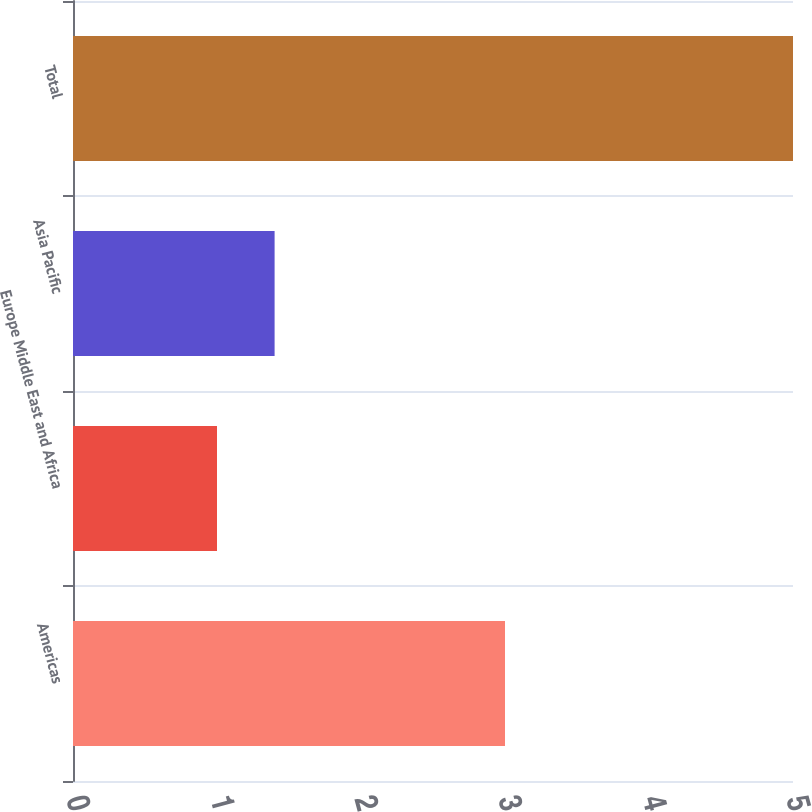Convert chart to OTSL. <chart><loc_0><loc_0><loc_500><loc_500><bar_chart><fcel>Americas<fcel>Europe Middle East and Africa<fcel>Asia Pacific<fcel>Total<nl><fcel>3<fcel>1<fcel>1.4<fcel>5<nl></chart> 